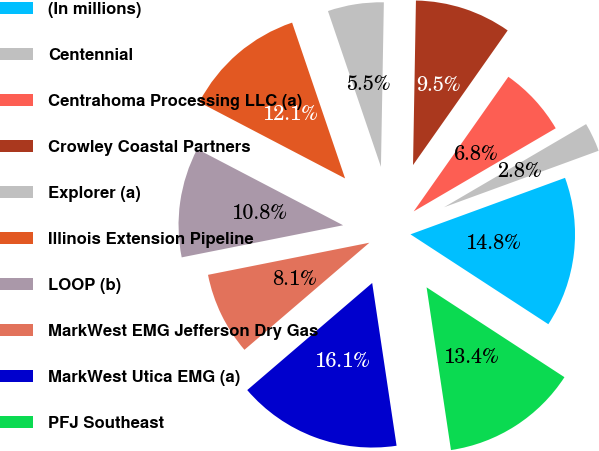<chart> <loc_0><loc_0><loc_500><loc_500><pie_chart><fcel>(In millions)<fcel>Centennial<fcel>Centrahoma Processing LLC (a)<fcel>Crowley Coastal Partners<fcel>Explorer (a)<fcel>Illinois Extension Pipeline<fcel>LOOP (b)<fcel>MarkWest EMG Jefferson Dry Gas<fcel>MarkWest Utica EMG (a)<fcel>PFJ Southeast<nl><fcel>14.77%<fcel>2.85%<fcel>6.82%<fcel>9.47%<fcel>5.5%<fcel>12.12%<fcel>10.79%<fcel>8.15%<fcel>16.09%<fcel>13.44%<nl></chart> 